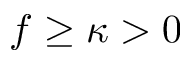Convert formula to latex. <formula><loc_0><loc_0><loc_500><loc_500>f \geq \kappa > 0</formula> 